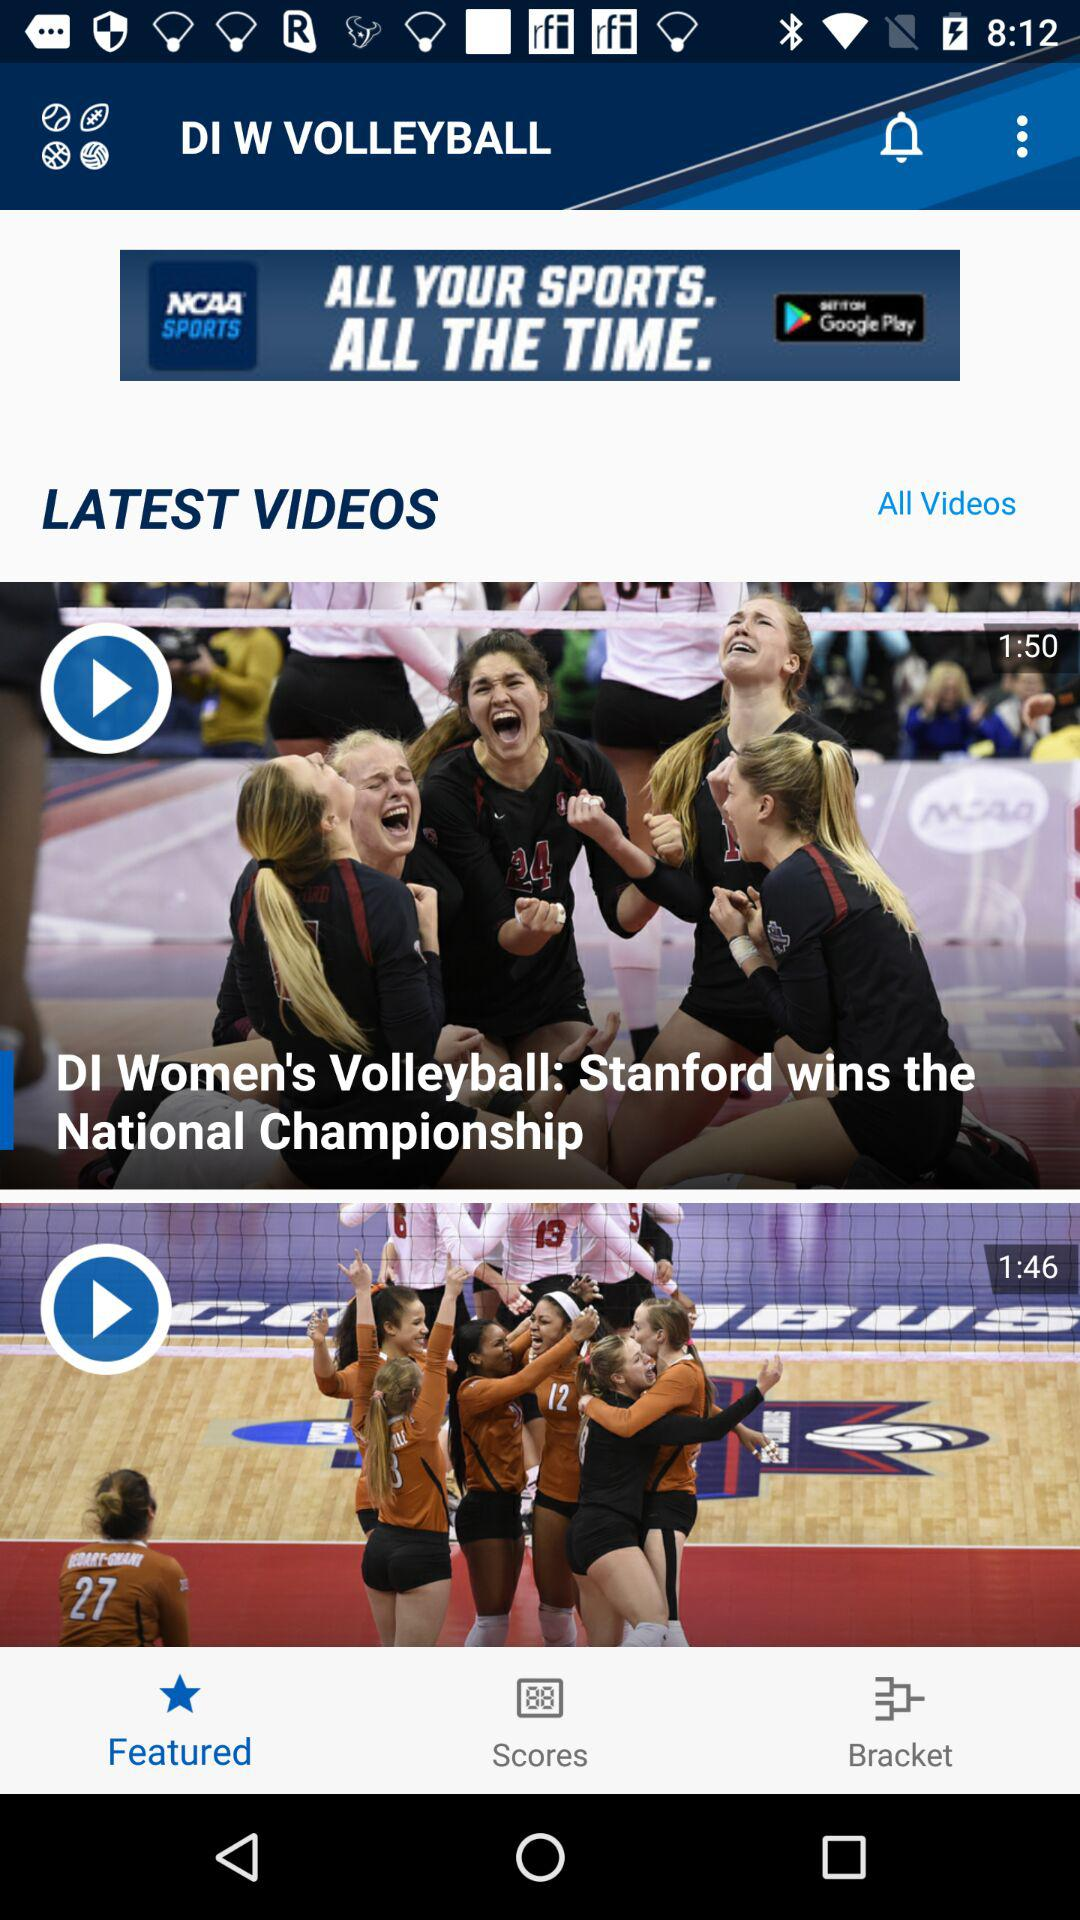What is the application name? The application name is "DI W VOLLEYBALL". 